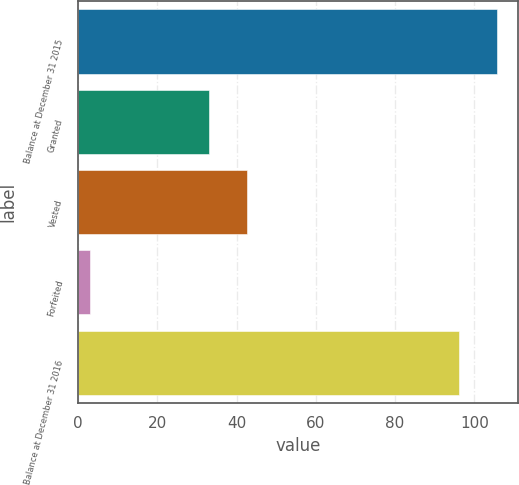Convert chart. <chart><loc_0><loc_0><loc_500><loc_500><bar_chart><fcel>Balance at December 31 2015<fcel>Granted<fcel>Vested<fcel>Forfeited<fcel>Balance at December 31 2016<nl><fcel>105.6<fcel>33<fcel>42.6<fcel>3<fcel>96<nl></chart> 